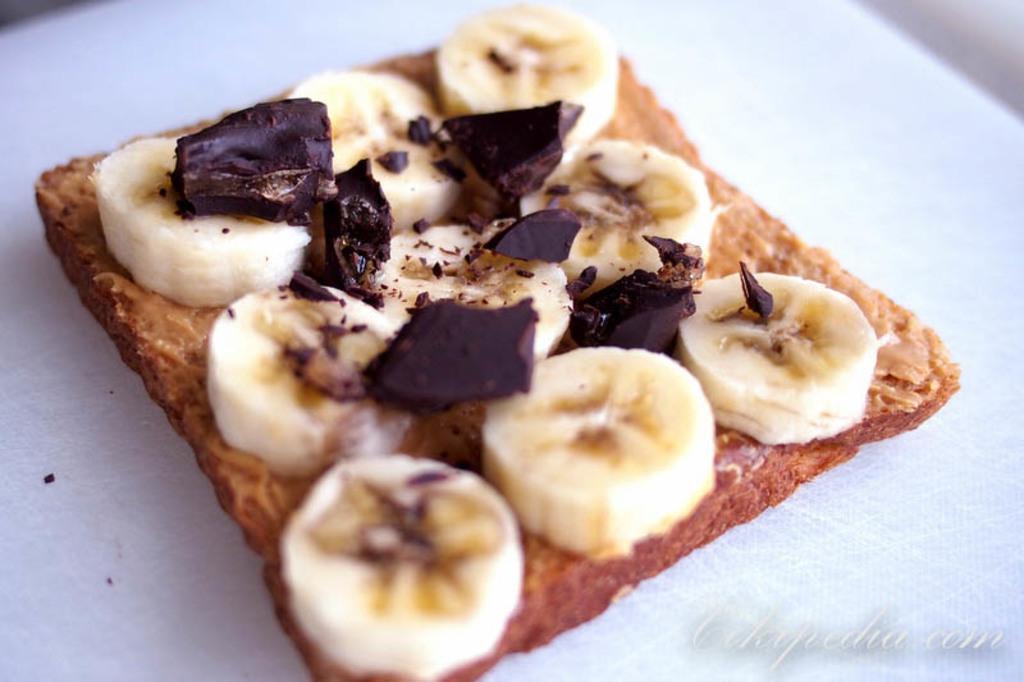How would you summarize this image in a sentence or two? In this picture we can see there are banana slices and some food items on a white object. On the image there is a watermark. 